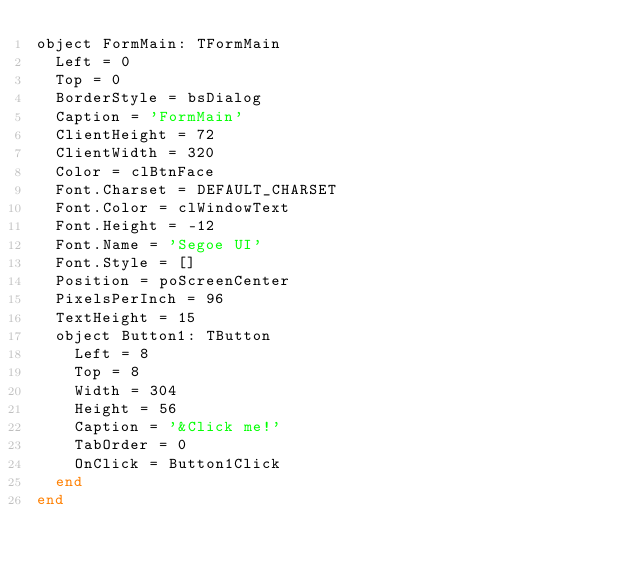<code> <loc_0><loc_0><loc_500><loc_500><_Pascal_>object FormMain: TFormMain
  Left = 0
  Top = 0
  BorderStyle = bsDialog
  Caption = 'FormMain'
  ClientHeight = 72
  ClientWidth = 320
  Color = clBtnFace
  Font.Charset = DEFAULT_CHARSET
  Font.Color = clWindowText
  Font.Height = -12
  Font.Name = 'Segoe UI'
  Font.Style = []
  Position = poScreenCenter
  PixelsPerInch = 96
  TextHeight = 15
  object Button1: TButton
    Left = 8
    Top = 8
    Width = 304
    Height = 56
    Caption = '&Click me!'
    TabOrder = 0
    OnClick = Button1Click
  end
end
</code> 